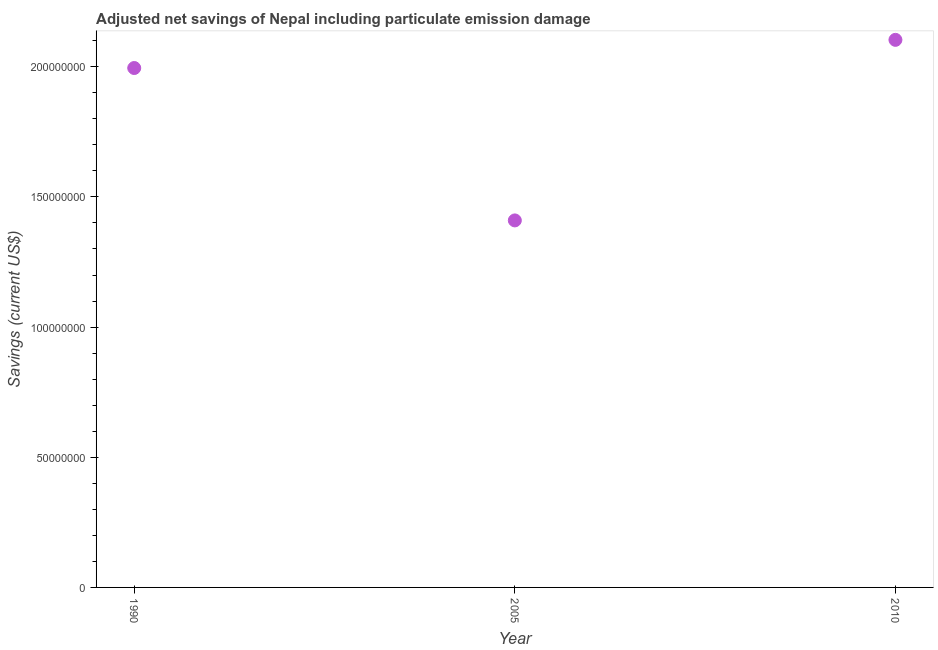What is the adjusted net savings in 2005?
Give a very brief answer. 1.41e+08. Across all years, what is the maximum adjusted net savings?
Your response must be concise. 2.10e+08. Across all years, what is the minimum adjusted net savings?
Provide a short and direct response. 1.41e+08. In which year was the adjusted net savings maximum?
Provide a short and direct response. 2010. What is the sum of the adjusted net savings?
Make the answer very short. 5.51e+08. What is the difference between the adjusted net savings in 1990 and 2010?
Offer a terse response. -1.08e+07. What is the average adjusted net savings per year?
Offer a terse response. 1.84e+08. What is the median adjusted net savings?
Your response must be concise. 2.00e+08. Do a majority of the years between 1990 and 2010 (inclusive) have adjusted net savings greater than 10000000 US$?
Offer a very short reply. Yes. What is the ratio of the adjusted net savings in 2005 to that in 2010?
Make the answer very short. 0.67. Is the difference between the adjusted net savings in 1990 and 2010 greater than the difference between any two years?
Offer a terse response. No. What is the difference between the highest and the second highest adjusted net savings?
Provide a succinct answer. 1.08e+07. What is the difference between the highest and the lowest adjusted net savings?
Your response must be concise. 6.94e+07. What is the difference between two consecutive major ticks on the Y-axis?
Keep it short and to the point. 5.00e+07. Does the graph contain any zero values?
Provide a succinct answer. No. Does the graph contain grids?
Ensure brevity in your answer.  No. What is the title of the graph?
Your response must be concise. Adjusted net savings of Nepal including particulate emission damage. What is the label or title of the Y-axis?
Offer a terse response. Savings (current US$). What is the Savings (current US$) in 1990?
Offer a terse response. 2.00e+08. What is the Savings (current US$) in 2005?
Provide a succinct answer. 1.41e+08. What is the Savings (current US$) in 2010?
Make the answer very short. 2.10e+08. What is the difference between the Savings (current US$) in 1990 and 2005?
Ensure brevity in your answer.  5.85e+07. What is the difference between the Savings (current US$) in 1990 and 2010?
Provide a succinct answer. -1.08e+07. What is the difference between the Savings (current US$) in 2005 and 2010?
Make the answer very short. -6.94e+07. What is the ratio of the Savings (current US$) in 1990 to that in 2005?
Offer a terse response. 1.42. What is the ratio of the Savings (current US$) in 1990 to that in 2010?
Your answer should be very brief. 0.95. What is the ratio of the Savings (current US$) in 2005 to that in 2010?
Give a very brief answer. 0.67. 